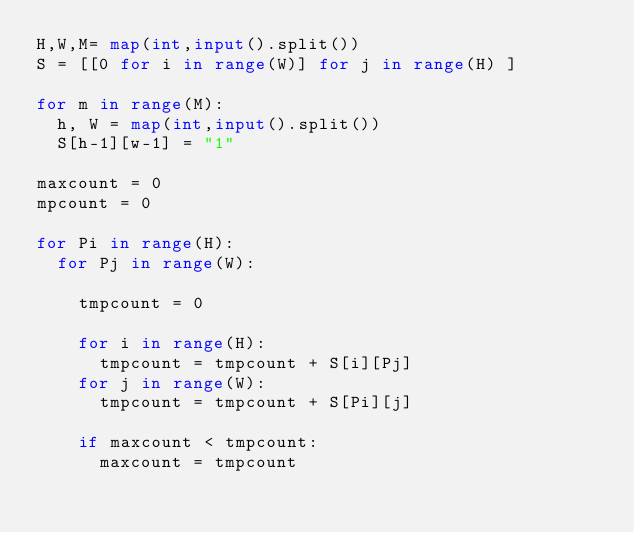<code> <loc_0><loc_0><loc_500><loc_500><_Python_>H,W,M= map(int,input().split())
S = [[0 for i in range(W)] for j in range(H) ]

for m in range(M):
  h, W = map(int,input().split())
  S[h-1][w-1] = "1"

maxcount = 0  
mpcount = 0  

for Pi in range(H):
  for Pj in range(W):
    
    tmpcount = 0
    
    for i in range(H):
      tmpcount = tmpcount + S[i][Pj]
    for j in range(W):
      tmpcount = tmpcount + S[Pi][j]
      
    if maxcount < tmpcount:
      maxcount = tmpcount</code> 